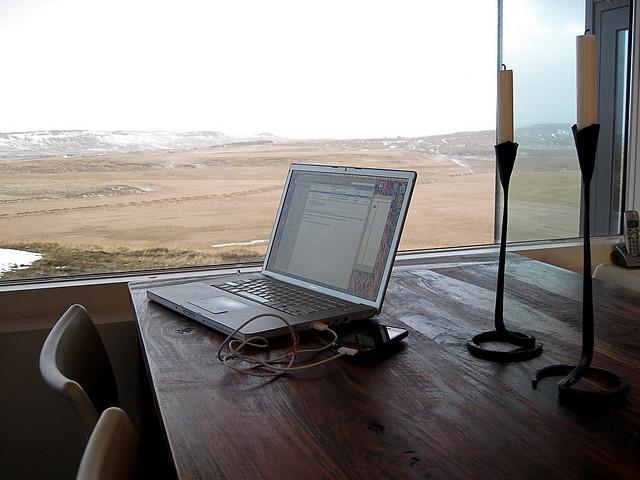Why are there candles on this table?
Answer briefly. Decoration. Where is the USB port?
Be succinct. Side. What is outside the window?
Write a very short answer. Desert. 